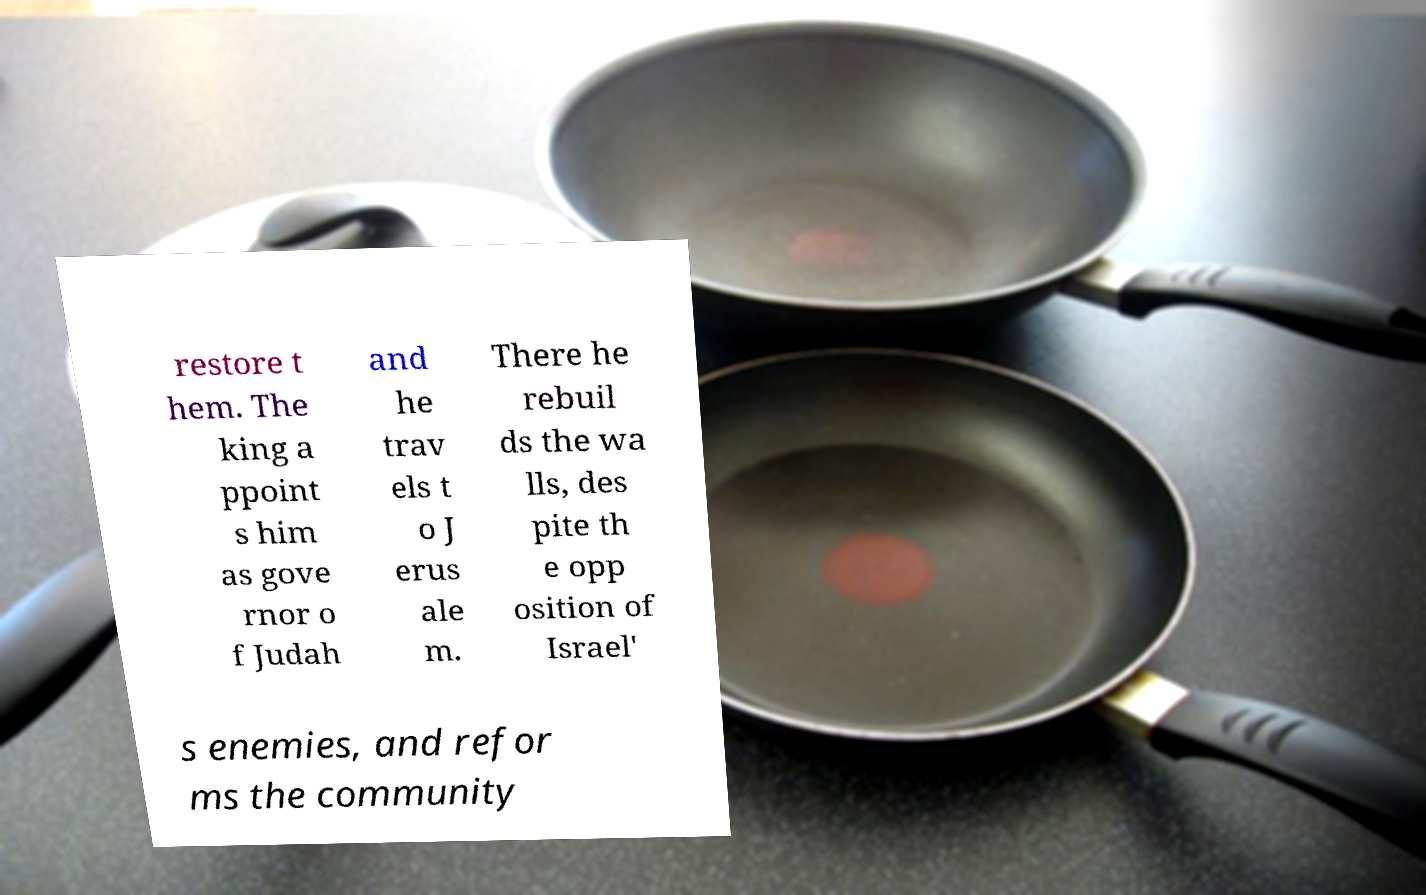Could you extract and type out the text from this image? restore t hem. The king a ppoint s him as gove rnor o f Judah and he trav els t o J erus ale m. There he rebuil ds the wa lls, des pite th e opp osition of Israel' s enemies, and refor ms the community 